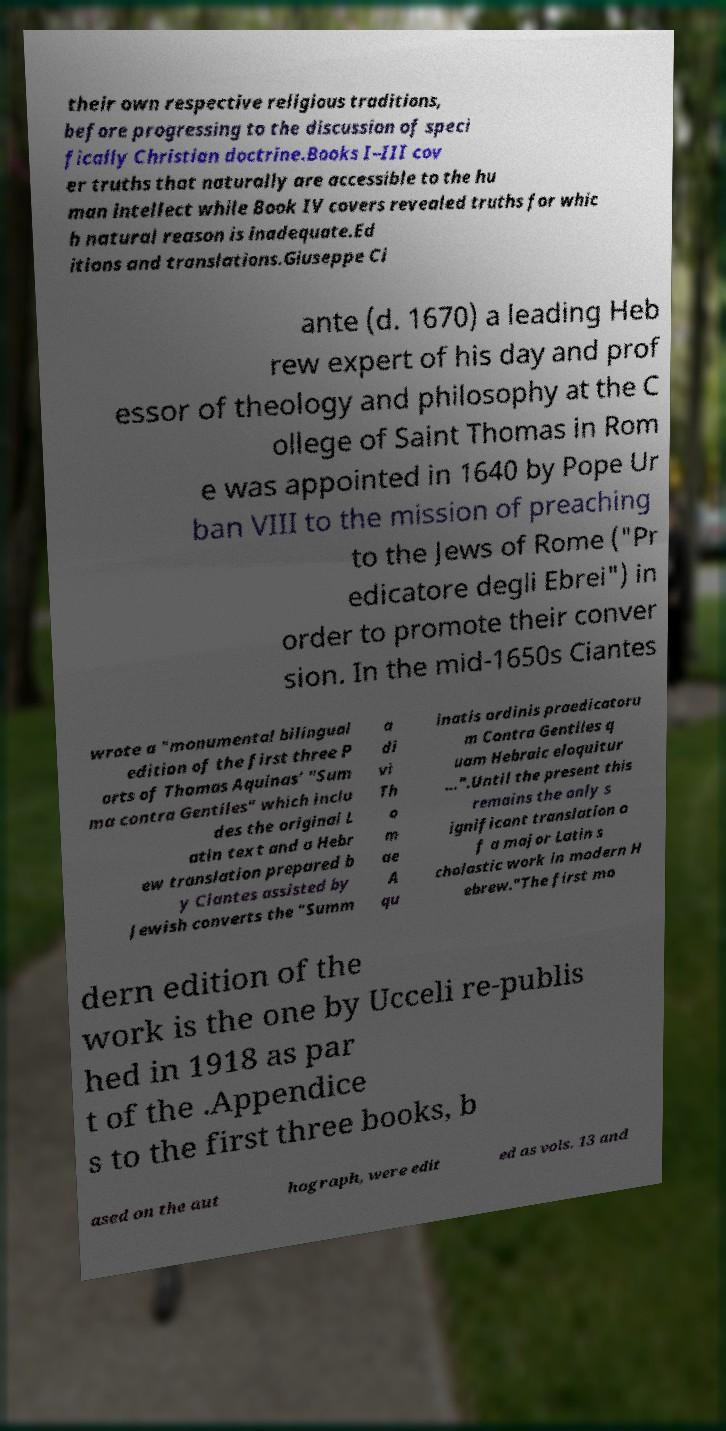There's text embedded in this image that I need extracted. Can you transcribe it verbatim? their own respective religious traditions, before progressing to the discussion of speci fically Christian doctrine.Books I–III cov er truths that naturally are accessible to the hu man intellect while Book IV covers revealed truths for whic h natural reason is inadequate.Ed itions and translations.Giuseppe Ci ante (d. 1670) a leading Heb rew expert of his day and prof essor of theology and philosophy at the C ollege of Saint Thomas in Rom e was appointed in 1640 by Pope Ur ban VIII to the mission of preaching to the Jews of Rome ("Pr edicatore degli Ebrei") in order to promote their conver sion. In the mid-1650s Ciantes wrote a "monumental bilingual edition of the first three P arts of Thomas Aquinas’ "Sum ma contra Gentiles" which inclu des the original L atin text and a Hebr ew translation prepared b y Ciantes assisted by Jewish converts the "Summ a di vi Th o m ae A qu inatis ordinis praedicatoru m Contra Gentiles q uam Hebraic eloquitur …".Until the present this remains the only s ignificant translation o f a major Latin s cholastic work in modern H ebrew."The first mo dern edition of the work is the one by Ucceli re-publis hed in 1918 as par t of the .Appendice s to the first three books, b ased on the aut hograph, were edit ed as vols. 13 and 